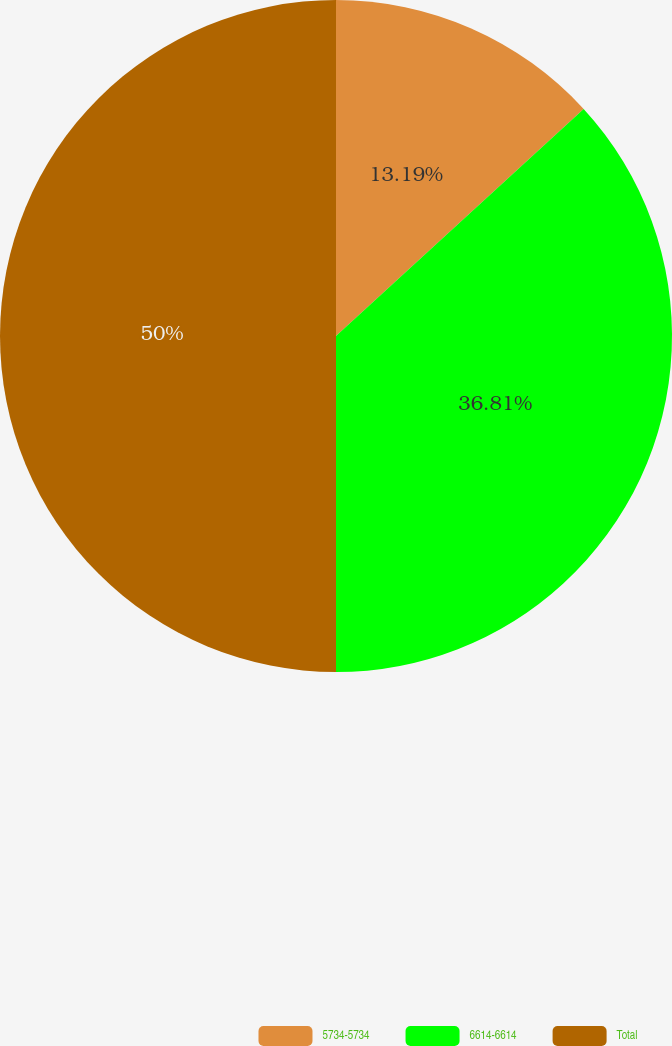Convert chart to OTSL. <chart><loc_0><loc_0><loc_500><loc_500><pie_chart><fcel>5734-5734<fcel>6614-6614<fcel>Total<nl><fcel>13.19%<fcel>36.81%<fcel>50.0%<nl></chart> 